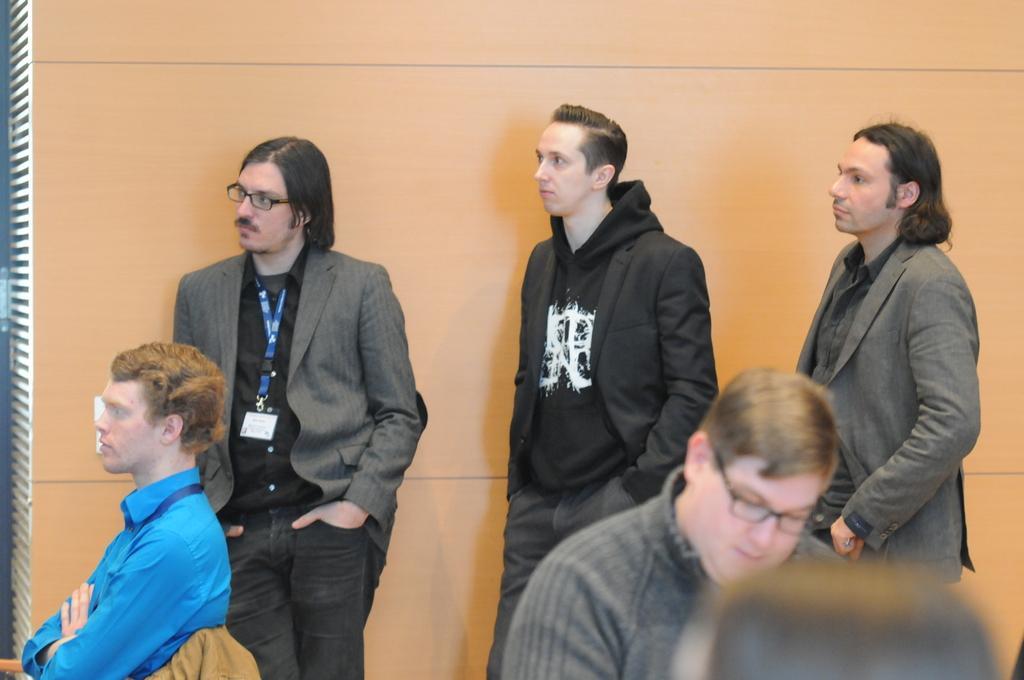Describe this image in one or two sentences. In this image there are three persons standing near the wall. A person wearing a blue shirt is sitting on the chair which is having a cloth on it. Bottom of image two persons are there. 